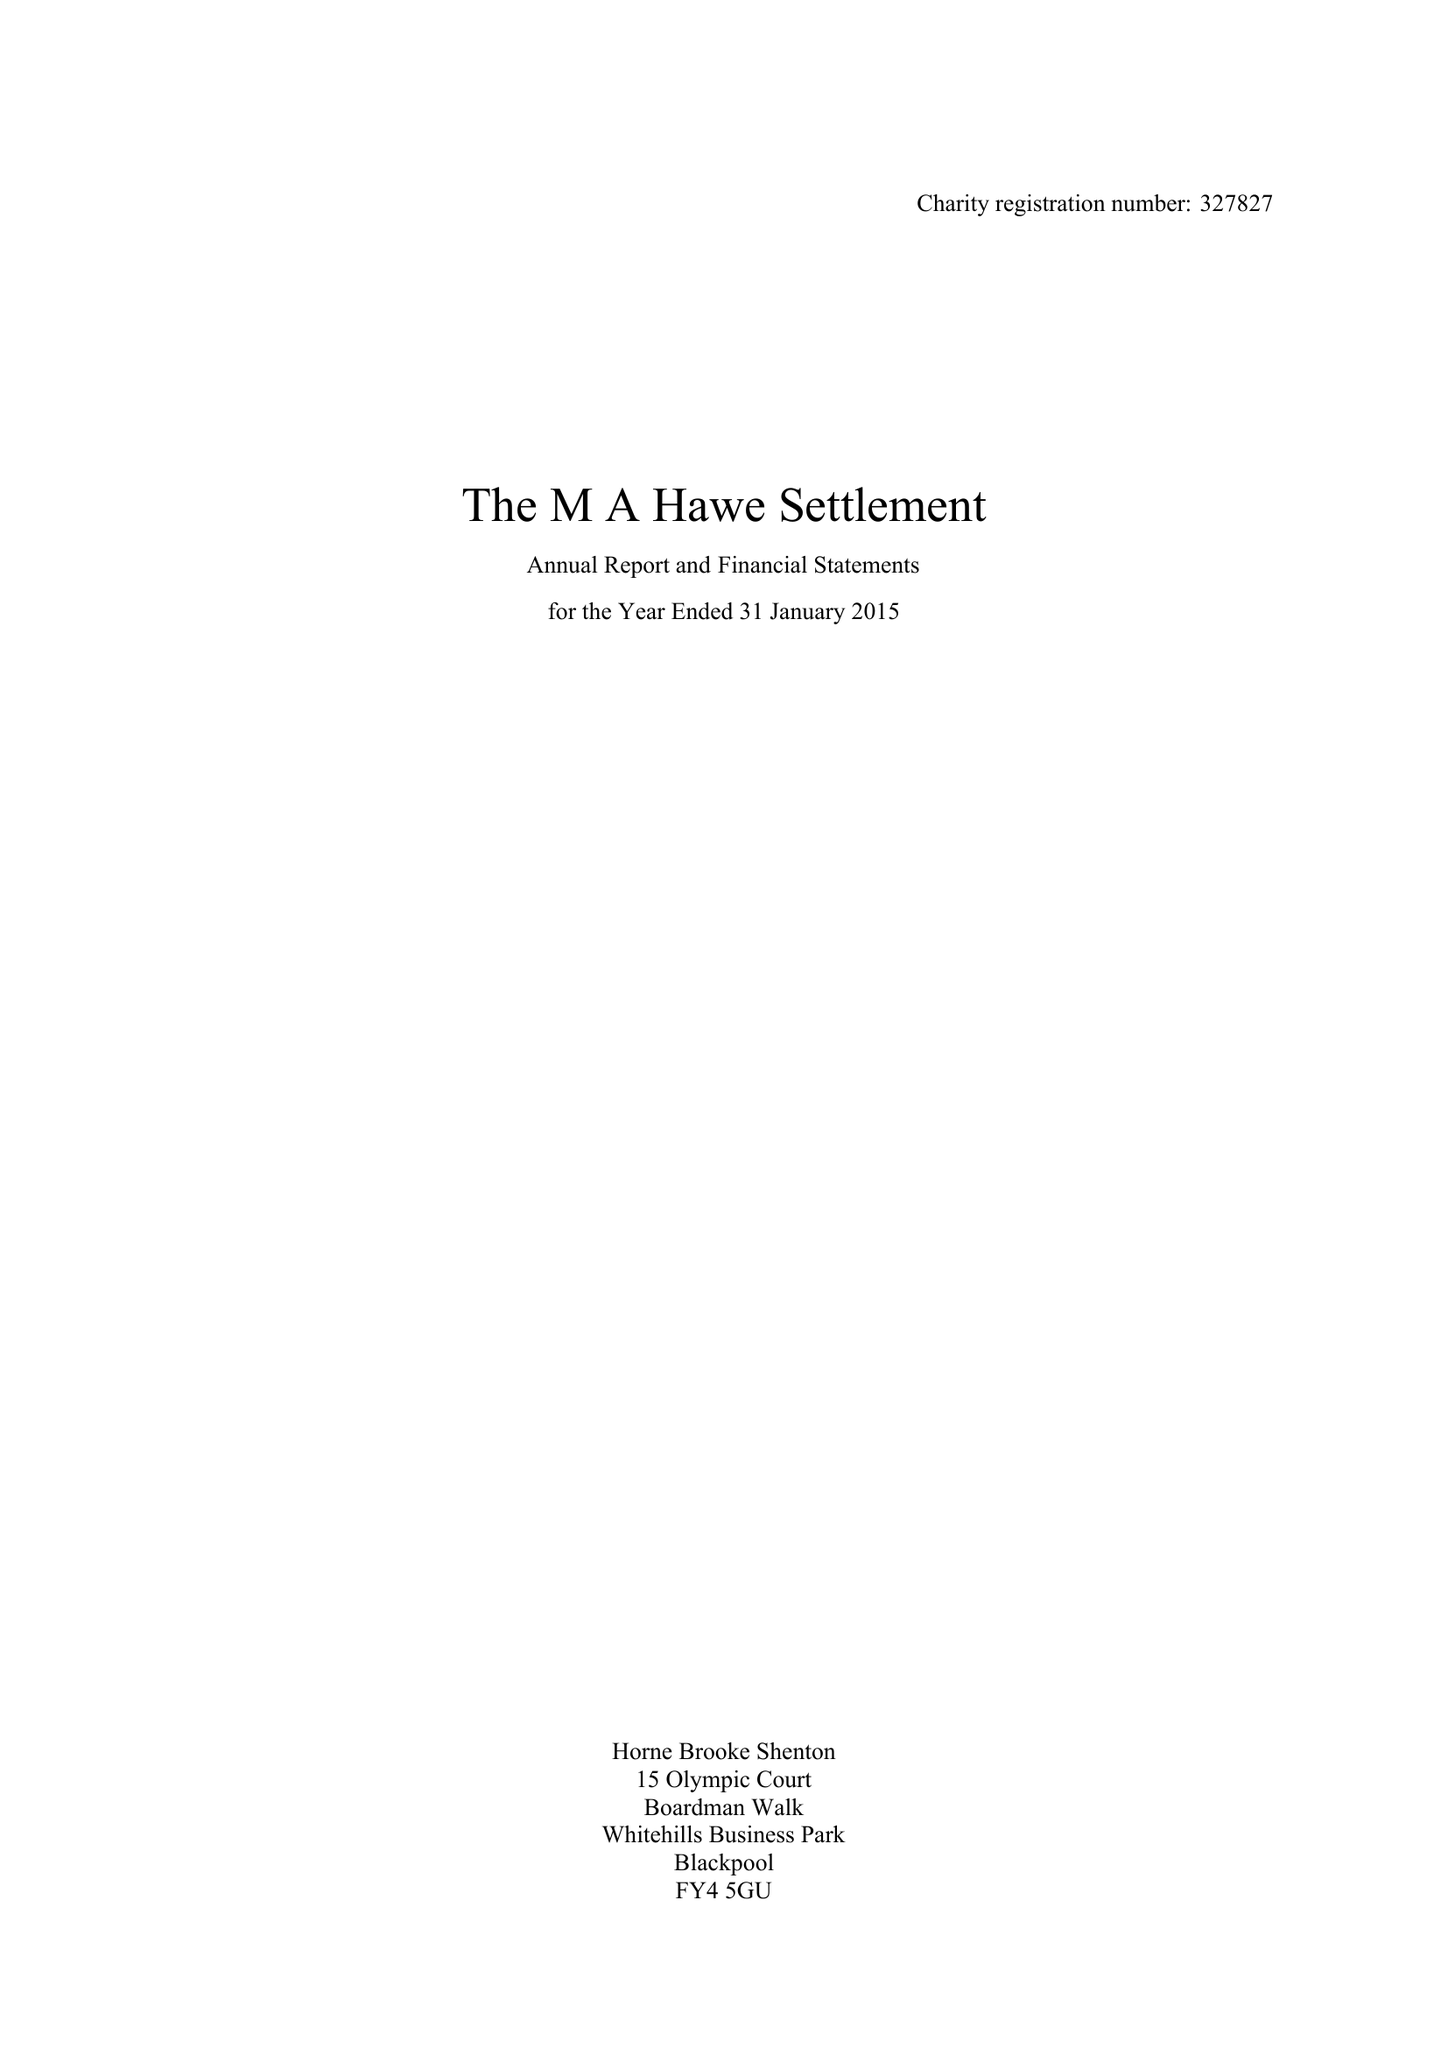What is the value for the address__postcode?
Answer the question using a single word or phrase. FY8 4JF 